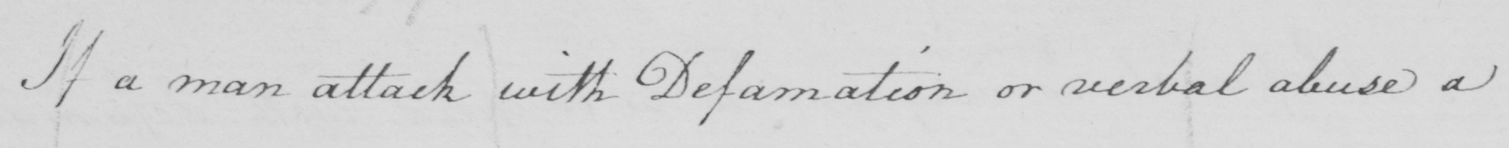Can you tell me what this handwritten text says? If a man attack with Defamation or verbal abuse a 